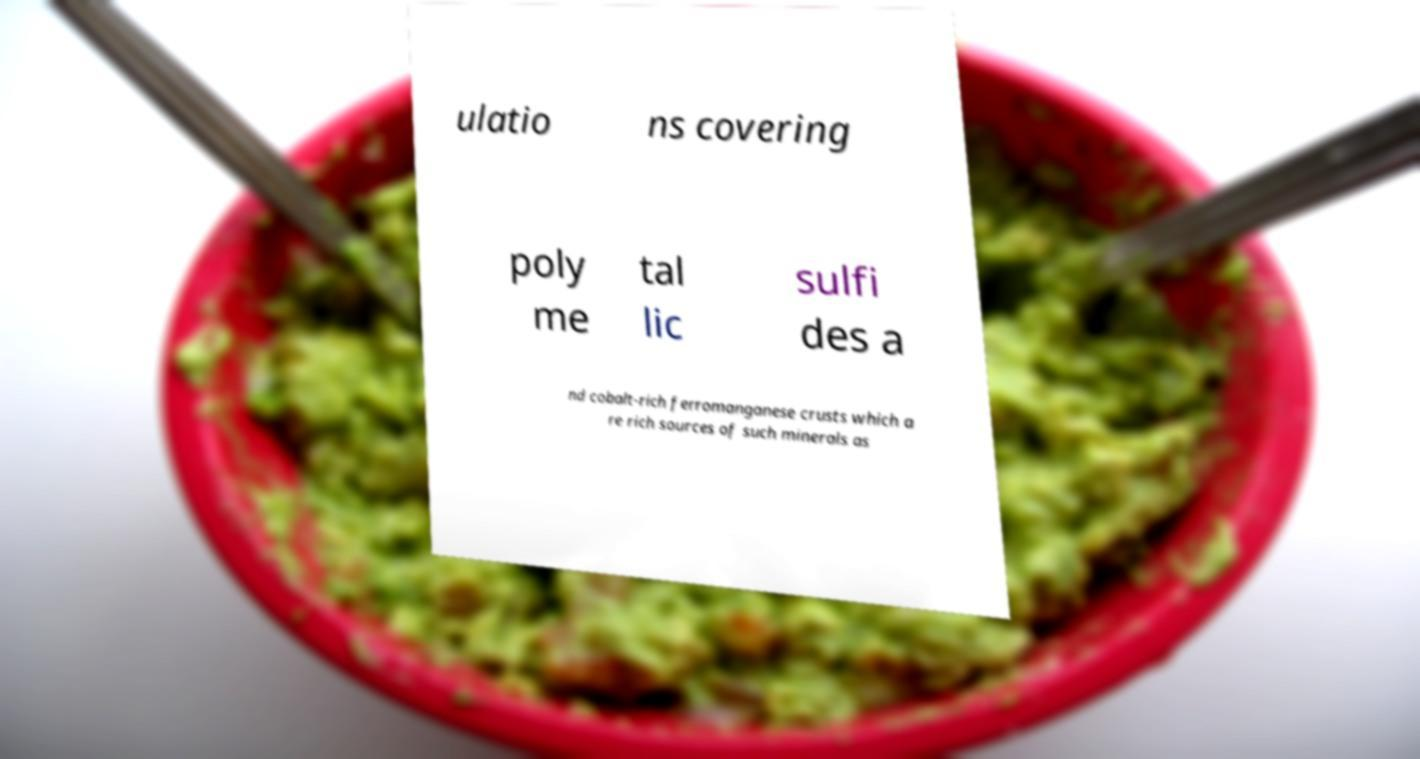What messages or text are displayed in this image? I need them in a readable, typed format. ulatio ns covering poly me tal lic sulfi des a nd cobalt-rich ferromanganese crusts which a re rich sources of such minerals as 